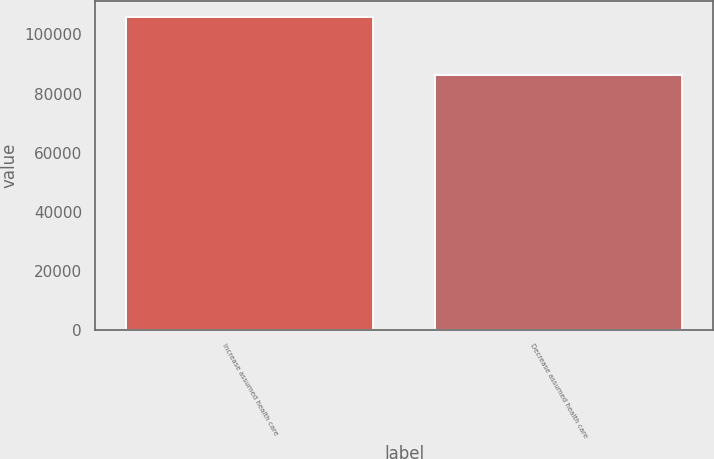Convert chart to OTSL. <chart><loc_0><loc_0><loc_500><loc_500><bar_chart><fcel>Increase assumed health care<fcel>Decrease assumed health care<nl><fcel>105967<fcel>86179<nl></chart> 